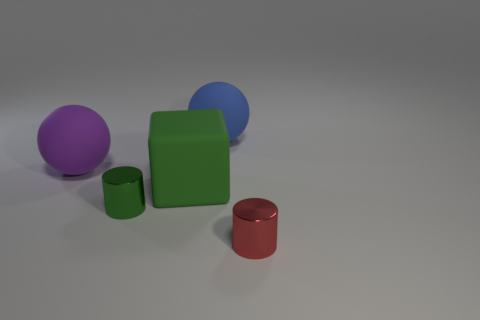The green thing that is the same size as the purple rubber object is what shape?
Provide a short and direct response. Cube. What color is the big cube that is the same material as the purple sphere?
Give a very brief answer. Green. There is a tiny green object; does it have the same shape as the metal object on the right side of the large blue thing?
Your response must be concise. Yes. There is a tiny object that is the same color as the rubber cube; what material is it?
Keep it short and to the point. Metal. What is the material of the other cylinder that is the same size as the green shiny cylinder?
Your answer should be very brief. Metal. Is there a rubber object that has the same color as the big rubber cube?
Give a very brief answer. No. What shape is the object that is left of the large cube and behind the large green object?
Provide a succinct answer. Sphere. What number of red cylinders are made of the same material as the big green cube?
Make the answer very short. 0. Is the number of big blue objects in front of the blue thing less than the number of tiny things that are behind the big green block?
Your answer should be compact. No. The object on the left side of the metal object that is on the left side of the sphere that is right of the small green cylinder is made of what material?
Keep it short and to the point. Rubber. 